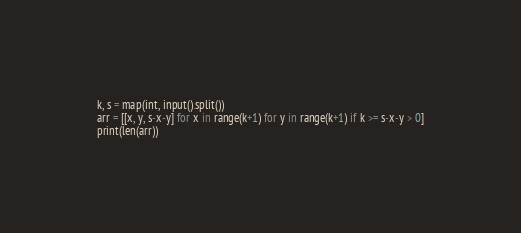<code> <loc_0><loc_0><loc_500><loc_500><_Python_>k, s = map(int, input().split())
arr = [[x, y, s-x-y] for x in range(k+1) for y in range(k+1) if k >= s-x-y > 0]
print(len(arr))</code> 